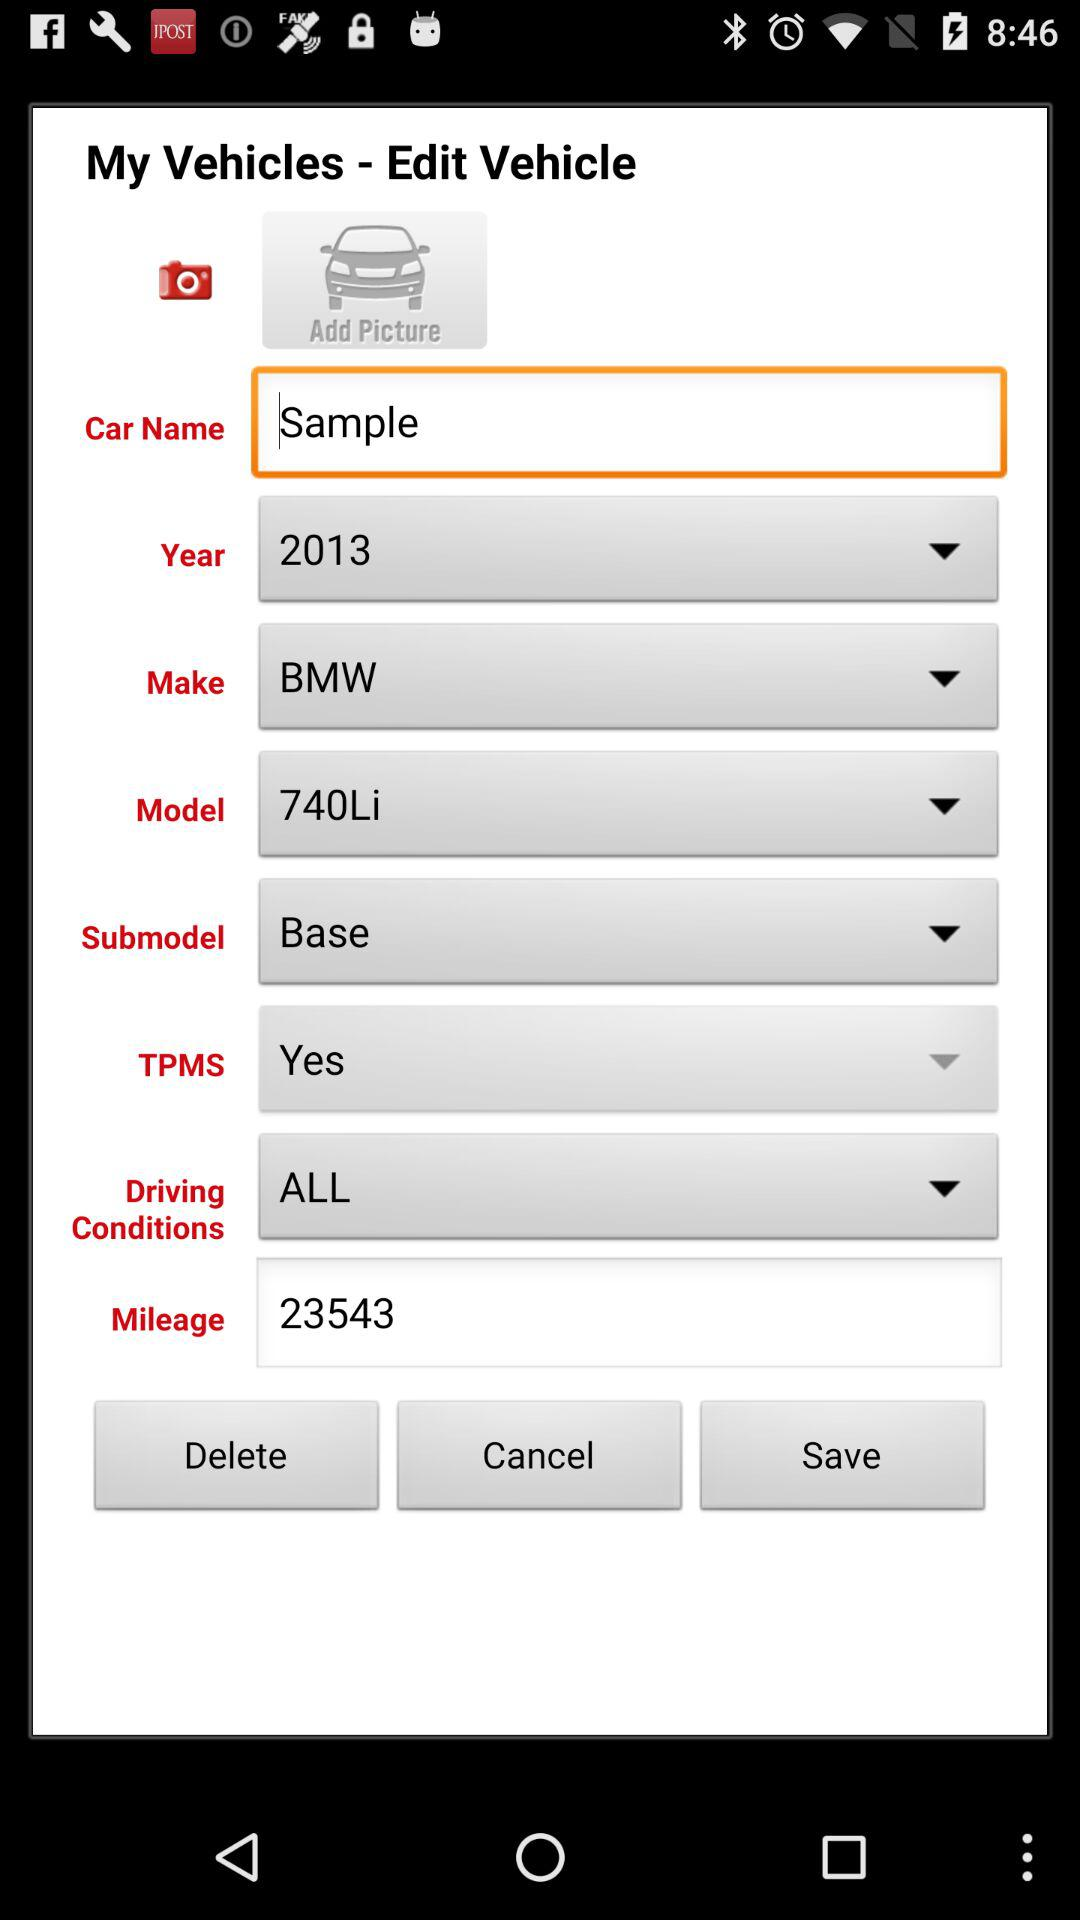What is the submodel? The submodel is "Base". 